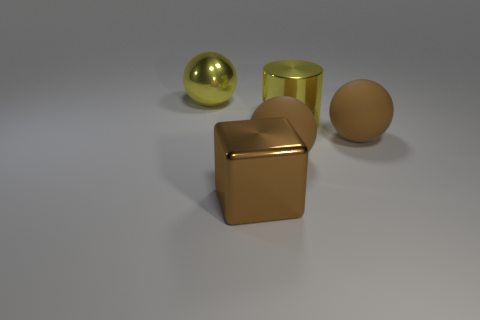Are there any other things that have the same shape as the brown metal object?
Ensure brevity in your answer.  No. Is the shiny cylinder the same color as the cube?
Ensure brevity in your answer.  No. Is the size of the brown matte ball to the right of the yellow cylinder the same as the large brown metallic object?
Offer a terse response. Yes. How many objects are to the right of the large thing left of the big brown metallic object?
Make the answer very short. 4. There is a big yellow thing that is right of the yellow object on the left side of the brown block; are there any large brown matte balls that are on the left side of it?
Provide a short and direct response. Yes. Is there anything else that has the same material as the big yellow ball?
Make the answer very short. Yes. Is the yellow ball made of the same material as the yellow thing that is in front of the large metallic sphere?
Ensure brevity in your answer.  Yes. What shape is the yellow metal thing left of the matte ball on the left side of the big yellow metal cylinder?
Your answer should be very brief. Sphere. How many tiny objects are brown blocks or brown spheres?
Make the answer very short. 0. What number of other large brown metal objects have the same shape as the brown shiny thing?
Offer a very short reply. 0. 